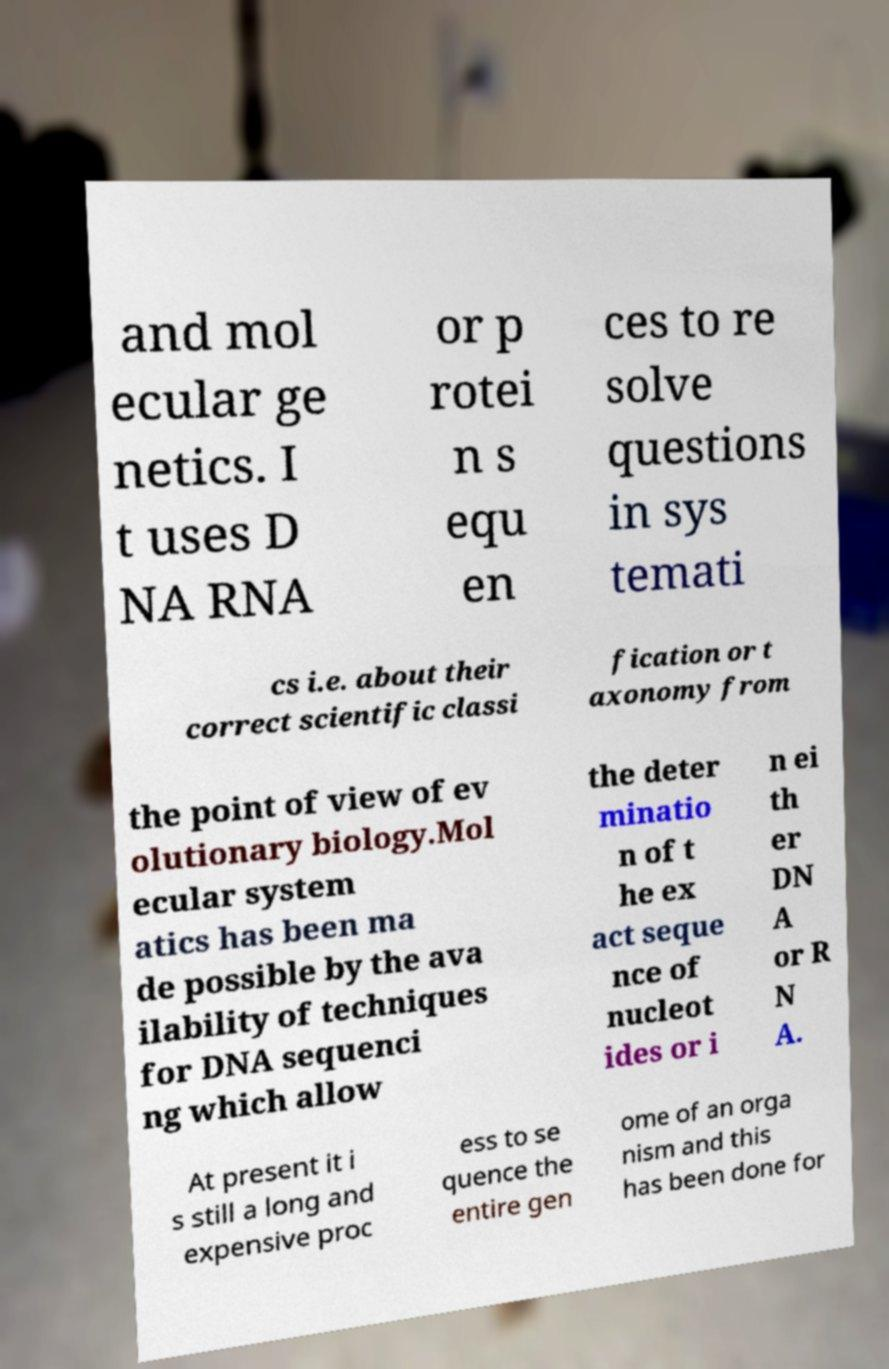Please identify and transcribe the text found in this image. and mol ecular ge netics. I t uses D NA RNA or p rotei n s equ en ces to re solve questions in sys temati cs i.e. about their correct scientific classi fication or t axonomy from the point of view of ev olutionary biology.Mol ecular system atics has been ma de possible by the ava ilability of techniques for DNA sequenci ng which allow the deter minatio n of t he ex act seque nce of nucleot ides or i n ei th er DN A or R N A. At present it i s still a long and expensive proc ess to se quence the entire gen ome of an orga nism and this has been done for 